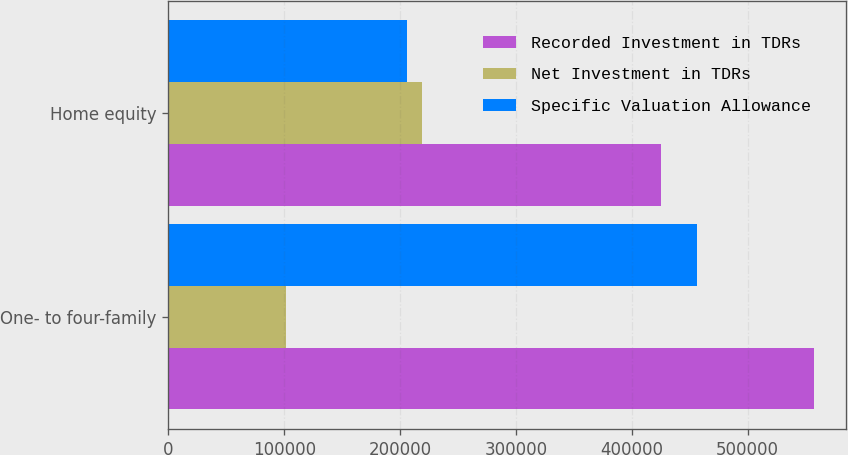<chart> <loc_0><loc_0><loc_500><loc_500><stacked_bar_chart><ecel><fcel>One- to four-family<fcel>Home equity<nl><fcel>Recorded Investment in TDRs<fcel>557297<fcel>424834<nl><fcel>Net Investment in TDRs<fcel>101188<fcel>218955<nl><fcel>Specific Valuation Allowance<fcel>456109<fcel>205879<nl></chart> 